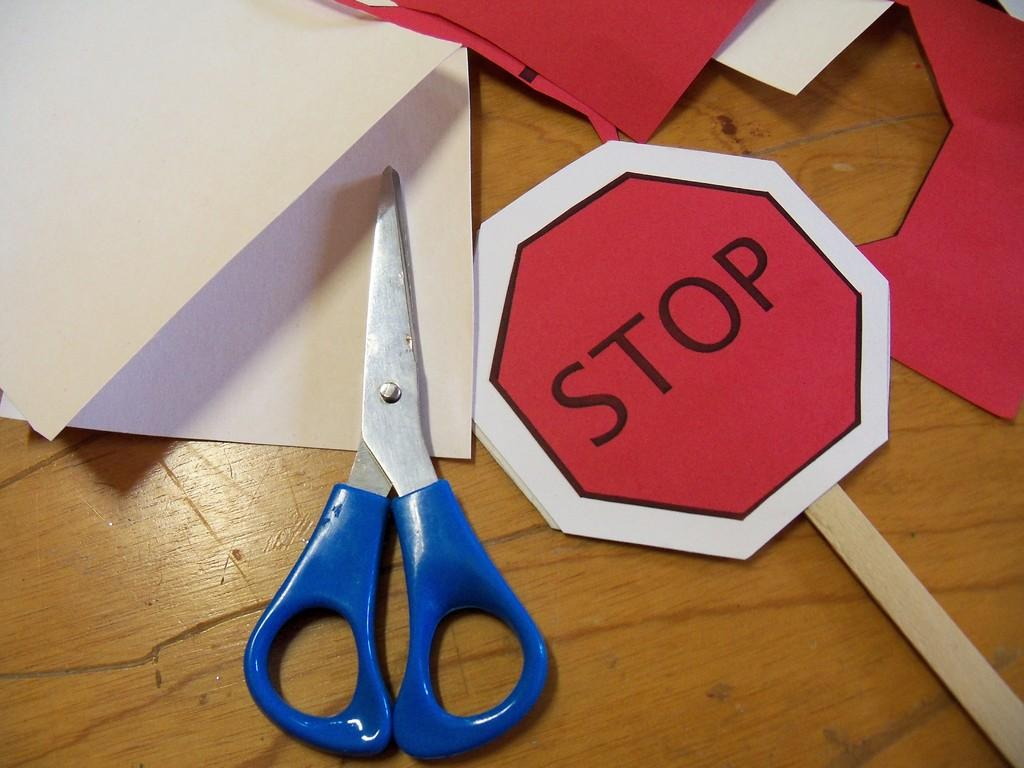<image>
Describe the image concisely. A pair of blue scissors beside a cut out Stop sign and card stock surrounding 